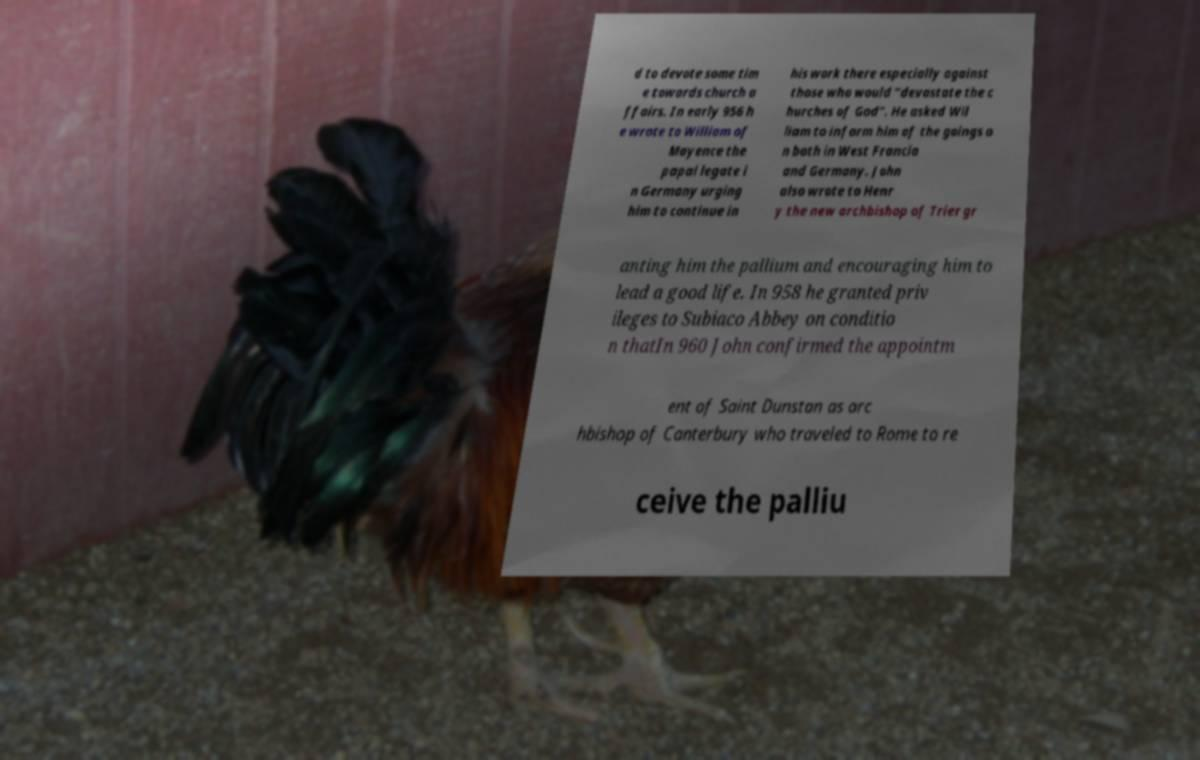I need the written content from this picture converted into text. Can you do that? d to devote some tim e towards church a ffairs. In early 956 h e wrote to William of Mayence the papal legate i n Germany urging him to continue in his work there especially against those who would “devastate the c hurches of God”. He asked Wil liam to inform him of the goings o n both in West Francia and Germany. John also wrote to Henr y the new archbishop of Trier gr anting him the pallium and encouraging him to lead a good life. In 958 he granted priv ileges to Subiaco Abbey on conditio n thatIn 960 John confirmed the appointm ent of Saint Dunstan as arc hbishop of Canterbury who traveled to Rome to re ceive the palliu 